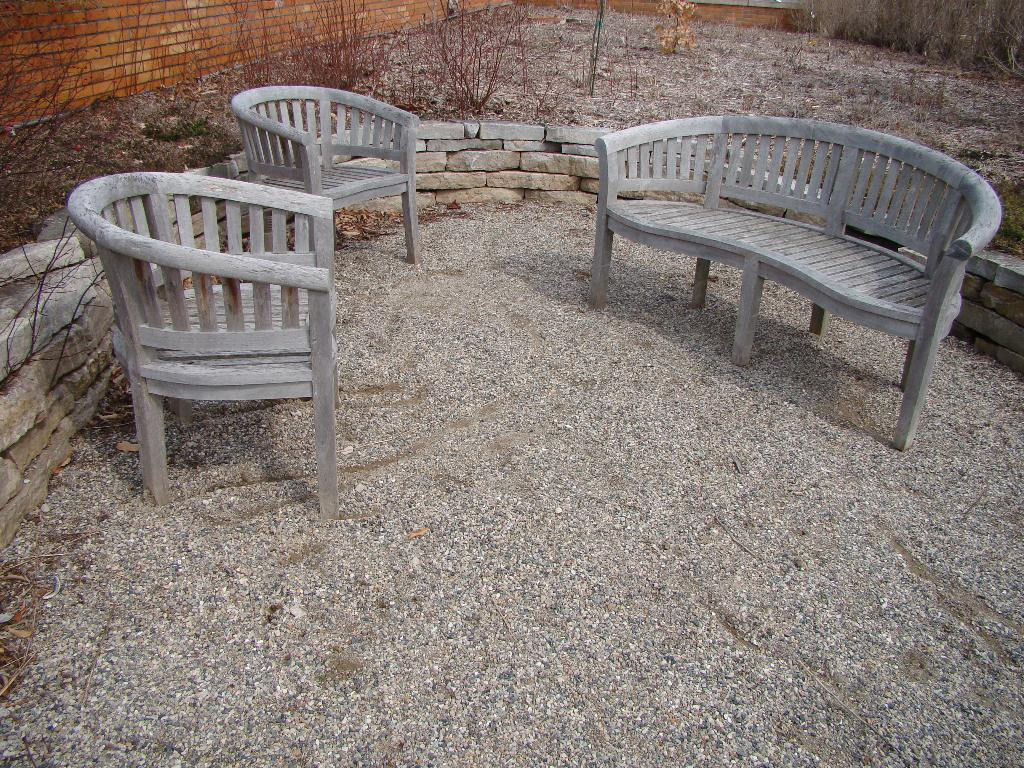What type of furniture is present in the image? There are chairs in the image. Where are the chairs located? The chairs are on small rocks. What surrounds the chairs? There is a fence around the chairs. What material is the fence made of? The fence is made of rocks. What can be seen in the background of the image? There are plants and a fence wall in the background of the image. How many eggs can be seen in the image? There are no eggs present in the image. What type of mass is visible in the image? There is no mass mentioned or visible in the image. 